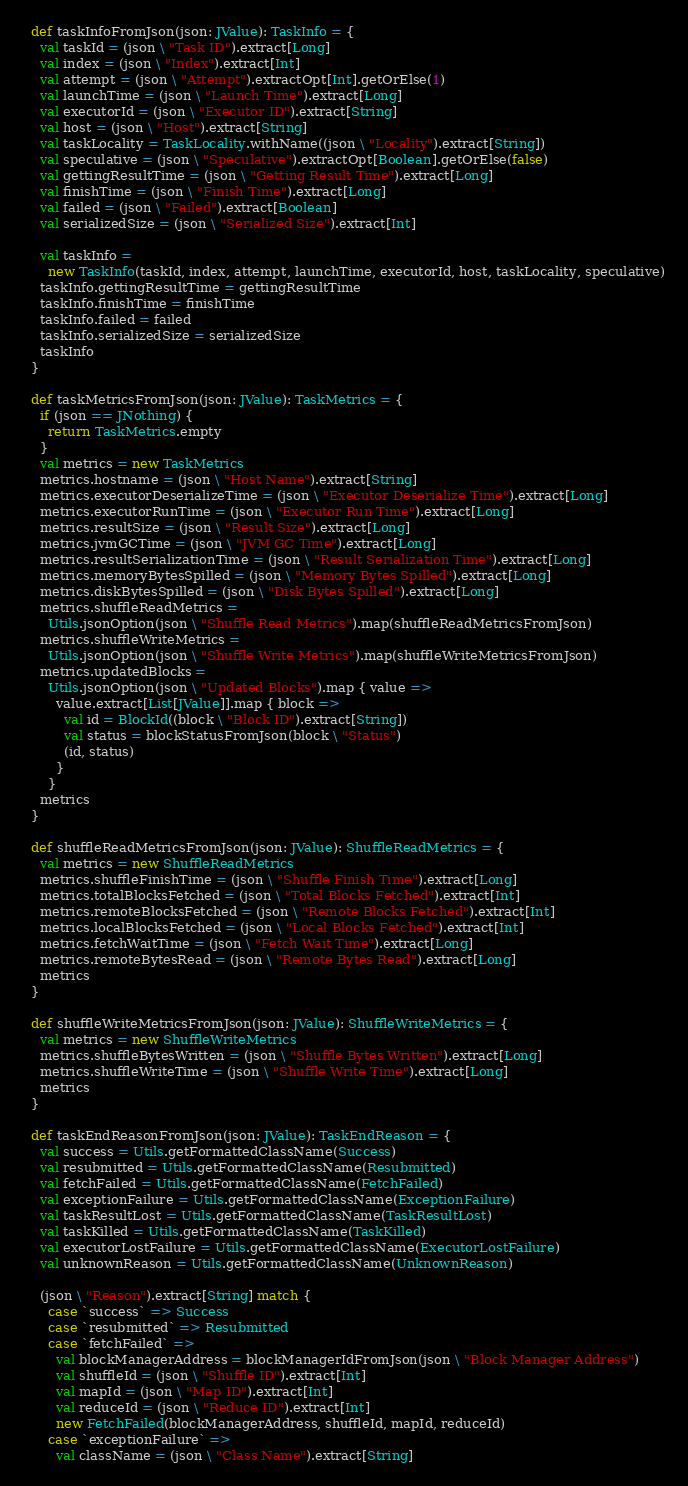Convert code to text. <code><loc_0><loc_0><loc_500><loc_500><_Scala_>  def taskInfoFromJson(json: JValue): TaskInfo = {
    val taskId = (json \ "Task ID").extract[Long]
    val index = (json \ "Index").extract[Int]
    val attempt = (json \ "Attempt").extractOpt[Int].getOrElse(1)
    val launchTime = (json \ "Launch Time").extract[Long]
    val executorId = (json \ "Executor ID").extract[String]
    val host = (json \ "Host").extract[String]
    val taskLocality = TaskLocality.withName((json \ "Locality").extract[String])
    val speculative = (json \ "Speculative").extractOpt[Boolean].getOrElse(false)
    val gettingResultTime = (json \ "Getting Result Time").extract[Long]
    val finishTime = (json \ "Finish Time").extract[Long]
    val failed = (json \ "Failed").extract[Boolean]
    val serializedSize = (json \ "Serialized Size").extract[Int]

    val taskInfo =
      new TaskInfo(taskId, index, attempt, launchTime, executorId, host, taskLocality, speculative)
    taskInfo.gettingResultTime = gettingResultTime
    taskInfo.finishTime = finishTime
    taskInfo.failed = failed
    taskInfo.serializedSize = serializedSize
    taskInfo
  }

  def taskMetricsFromJson(json: JValue): TaskMetrics = {
    if (json == JNothing) {
      return TaskMetrics.empty
    }
    val metrics = new TaskMetrics
    metrics.hostname = (json \ "Host Name").extract[String]
    metrics.executorDeserializeTime = (json \ "Executor Deserialize Time").extract[Long]
    metrics.executorRunTime = (json \ "Executor Run Time").extract[Long]
    metrics.resultSize = (json \ "Result Size").extract[Long]
    metrics.jvmGCTime = (json \ "JVM GC Time").extract[Long]
    metrics.resultSerializationTime = (json \ "Result Serialization Time").extract[Long]
    metrics.memoryBytesSpilled = (json \ "Memory Bytes Spilled").extract[Long]
    metrics.diskBytesSpilled = (json \ "Disk Bytes Spilled").extract[Long]
    metrics.shuffleReadMetrics =
      Utils.jsonOption(json \ "Shuffle Read Metrics").map(shuffleReadMetricsFromJson)
    metrics.shuffleWriteMetrics =
      Utils.jsonOption(json \ "Shuffle Write Metrics").map(shuffleWriteMetricsFromJson)
    metrics.updatedBlocks =
      Utils.jsonOption(json \ "Updated Blocks").map { value =>
        value.extract[List[JValue]].map { block =>
          val id = BlockId((block \ "Block ID").extract[String])
          val status = blockStatusFromJson(block \ "Status")
          (id, status)
        }
      }
    metrics
  }

  def shuffleReadMetricsFromJson(json: JValue): ShuffleReadMetrics = {
    val metrics = new ShuffleReadMetrics
    metrics.shuffleFinishTime = (json \ "Shuffle Finish Time").extract[Long]
    metrics.totalBlocksFetched = (json \ "Total Blocks Fetched").extract[Int]
    metrics.remoteBlocksFetched = (json \ "Remote Blocks Fetched").extract[Int]
    metrics.localBlocksFetched = (json \ "Local Blocks Fetched").extract[Int]
    metrics.fetchWaitTime = (json \ "Fetch Wait Time").extract[Long]
    metrics.remoteBytesRead = (json \ "Remote Bytes Read").extract[Long]
    metrics
  }

  def shuffleWriteMetricsFromJson(json: JValue): ShuffleWriteMetrics = {
    val metrics = new ShuffleWriteMetrics
    metrics.shuffleBytesWritten = (json \ "Shuffle Bytes Written").extract[Long]
    metrics.shuffleWriteTime = (json \ "Shuffle Write Time").extract[Long]
    metrics
  }

  def taskEndReasonFromJson(json: JValue): TaskEndReason = {
    val success = Utils.getFormattedClassName(Success)
    val resubmitted = Utils.getFormattedClassName(Resubmitted)
    val fetchFailed = Utils.getFormattedClassName(FetchFailed)
    val exceptionFailure = Utils.getFormattedClassName(ExceptionFailure)
    val taskResultLost = Utils.getFormattedClassName(TaskResultLost)
    val taskKilled = Utils.getFormattedClassName(TaskKilled)
    val executorLostFailure = Utils.getFormattedClassName(ExecutorLostFailure)
    val unknownReason = Utils.getFormattedClassName(UnknownReason)

    (json \ "Reason").extract[String] match {
      case `success` => Success
      case `resubmitted` => Resubmitted
      case `fetchFailed` =>
        val blockManagerAddress = blockManagerIdFromJson(json \ "Block Manager Address")
        val shuffleId = (json \ "Shuffle ID").extract[Int]
        val mapId = (json \ "Map ID").extract[Int]
        val reduceId = (json \ "Reduce ID").extract[Int]
        new FetchFailed(blockManagerAddress, shuffleId, mapId, reduceId)
      case `exceptionFailure` =>
        val className = (json \ "Class Name").extract[String]</code> 